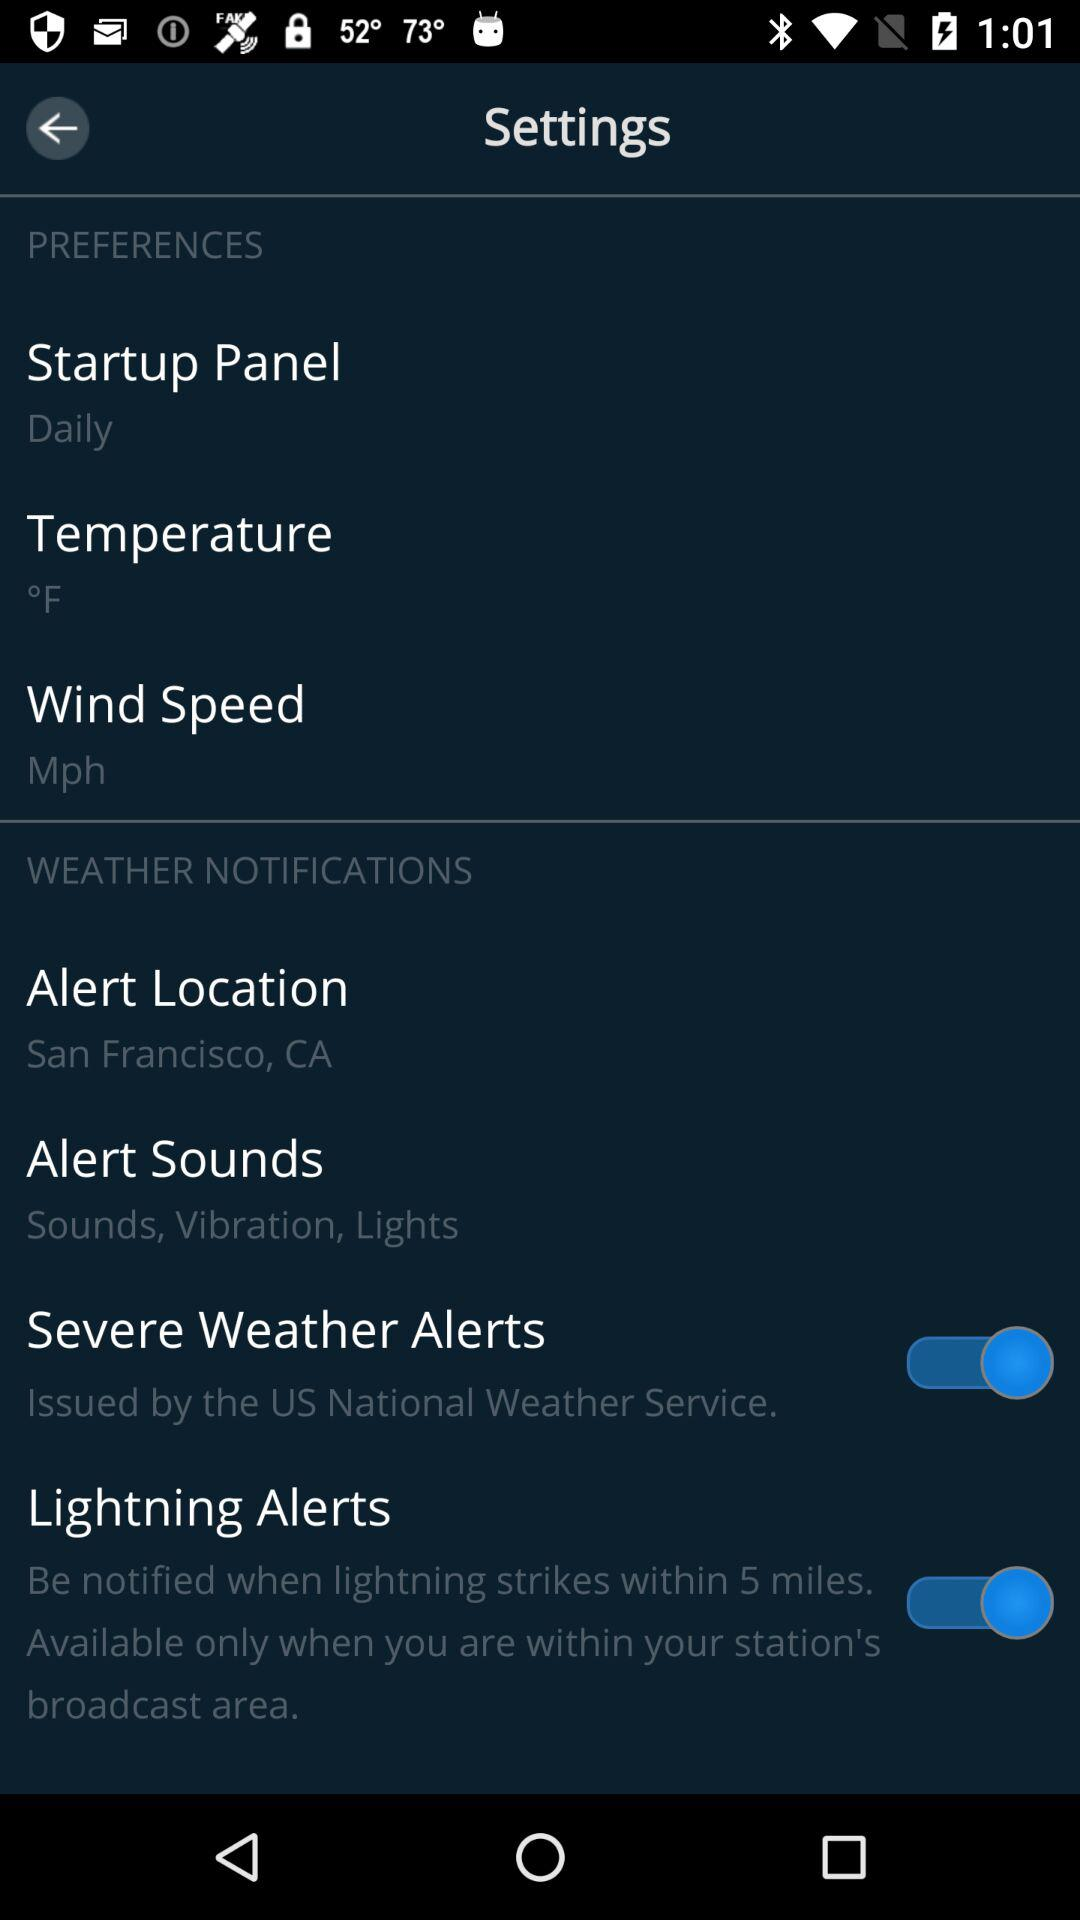How many items are under the "Weather Notifications" header?
Answer the question using a single word or phrase. 4 